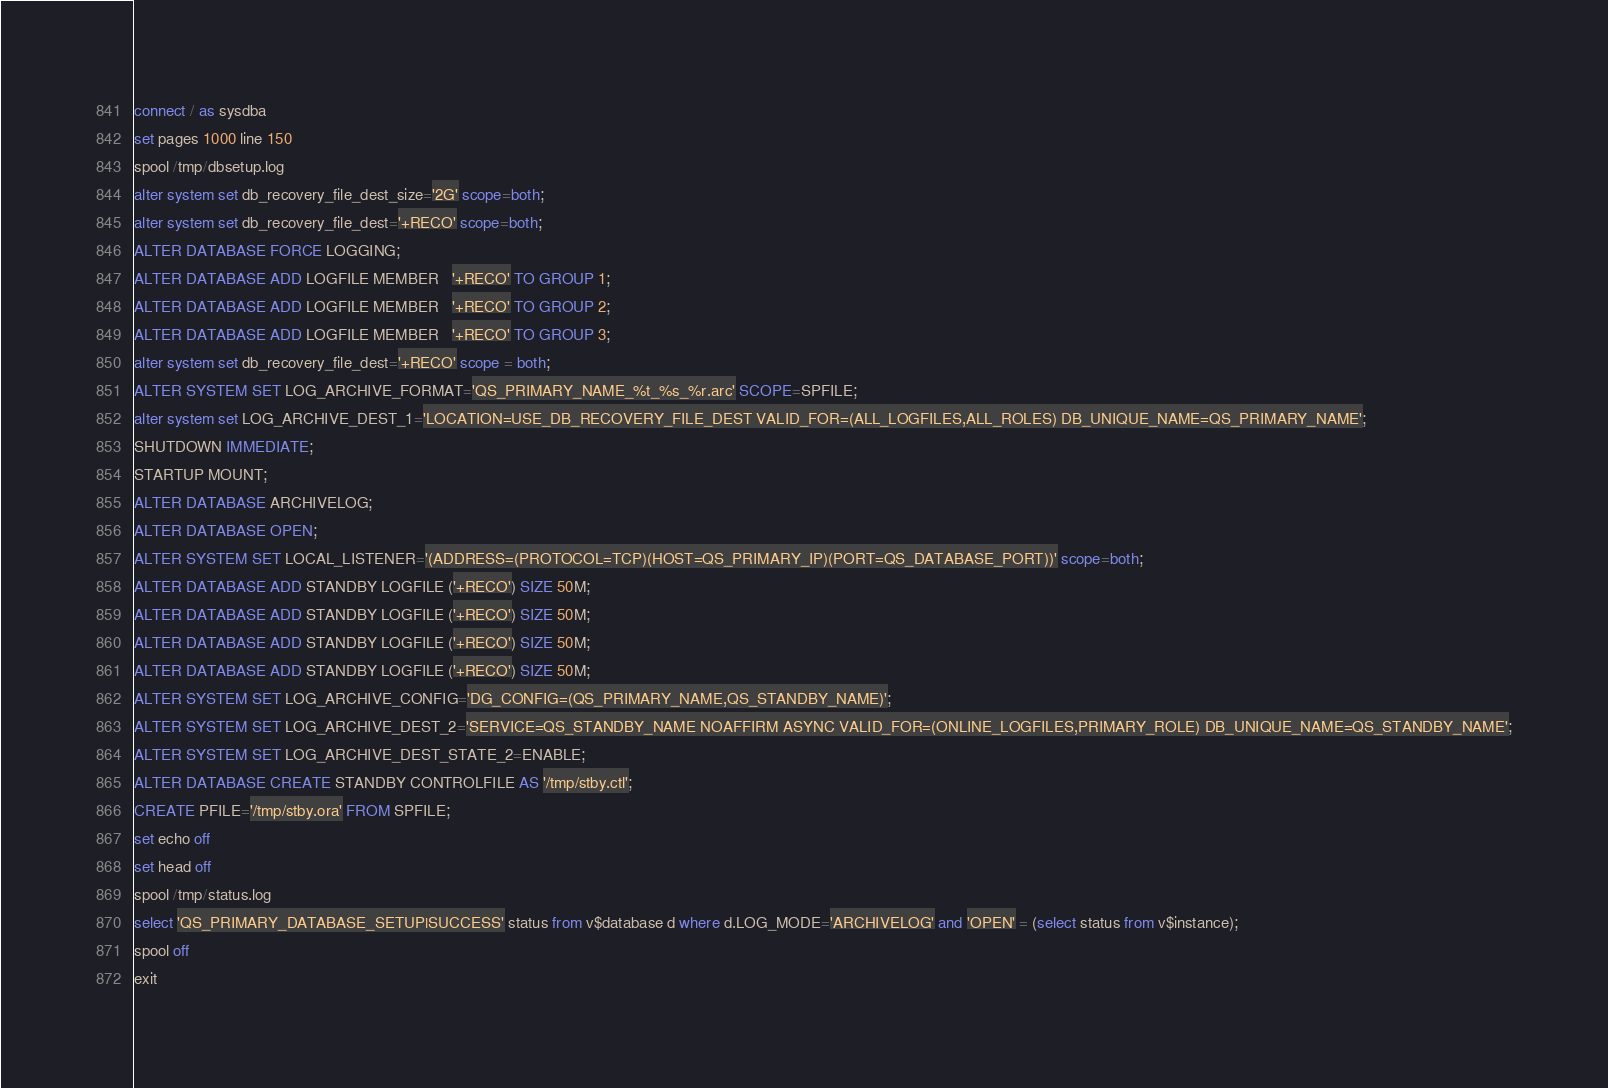Convert code to text. <code><loc_0><loc_0><loc_500><loc_500><_SQL_>connect / as sysdba
set pages 1000 line 150
spool /tmp/dbsetup.log
alter system set db_recovery_file_dest_size='2G' scope=both;
alter system set db_recovery_file_dest='+RECO' scope=both;
ALTER DATABASE FORCE LOGGING;
ALTER DATABASE ADD LOGFILE MEMBER   '+RECO' TO GROUP 1;
ALTER DATABASE ADD LOGFILE MEMBER   '+RECO' TO GROUP 2;
ALTER DATABASE ADD LOGFILE MEMBER   '+RECO' TO GROUP 3;
alter system set db_recovery_file_dest='+RECO' scope = both;
ALTER SYSTEM SET LOG_ARCHIVE_FORMAT='QS_PRIMARY_NAME_%t_%s_%r.arc' SCOPE=SPFILE;
alter system set LOG_ARCHIVE_DEST_1='LOCATION=USE_DB_RECOVERY_FILE_DEST VALID_FOR=(ALL_LOGFILES,ALL_ROLES) DB_UNIQUE_NAME=QS_PRIMARY_NAME';
SHUTDOWN IMMEDIATE;
STARTUP MOUNT;
ALTER DATABASE ARCHIVELOG;
ALTER DATABASE OPEN;
ALTER SYSTEM SET LOCAL_LISTENER='(ADDRESS=(PROTOCOL=TCP)(HOST=QS_PRIMARY_IP)(PORT=QS_DATABASE_PORT))' scope=both;
ALTER DATABASE ADD STANDBY LOGFILE ('+RECO') SIZE 50M;
ALTER DATABASE ADD STANDBY LOGFILE ('+RECO') SIZE 50M;
ALTER DATABASE ADD STANDBY LOGFILE ('+RECO') SIZE 50M;
ALTER DATABASE ADD STANDBY LOGFILE ('+RECO') SIZE 50M;
ALTER SYSTEM SET LOG_ARCHIVE_CONFIG='DG_CONFIG=(QS_PRIMARY_NAME,QS_STANDBY_NAME)';
ALTER SYSTEM SET LOG_ARCHIVE_DEST_2='SERVICE=QS_STANDBY_NAME NOAFFIRM ASYNC VALID_FOR=(ONLINE_LOGFILES,PRIMARY_ROLE) DB_UNIQUE_NAME=QS_STANDBY_NAME';
ALTER SYSTEM SET LOG_ARCHIVE_DEST_STATE_2=ENABLE;
ALTER DATABASE CREATE STANDBY CONTROLFILE AS '/tmp/stby.ctl';
CREATE PFILE='/tmp/stby.ora' FROM SPFILE;
set echo off
set head off
spool /tmp/status.log
select 'QS_PRIMARY_DATABASE_SETUP|SUCCESS' status from v$database d where d.LOG_MODE='ARCHIVELOG' and 'OPEN' = (select status from v$instance);
spool off
exit
</code> 